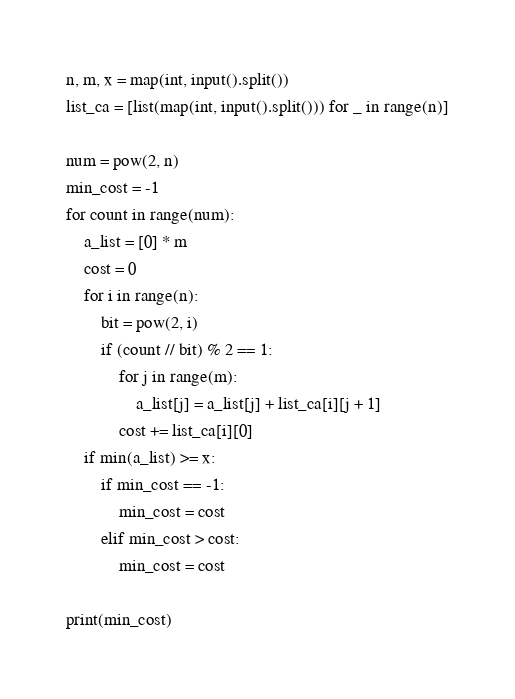<code> <loc_0><loc_0><loc_500><loc_500><_Python_>n, m, x = map(int, input().split())
list_ca = [list(map(int, input().split())) for _ in range(n)]

num = pow(2, n)
min_cost = -1
for count in range(num):
    a_list = [0] * m
    cost = 0
    for i in range(n):
        bit = pow(2, i)
        if (count // bit) % 2 == 1:
            for j in range(m):
                a_list[j] = a_list[j] + list_ca[i][j + 1]
            cost += list_ca[i][0]
    if min(a_list) >= x:
        if min_cost == -1:
            min_cost = cost
        elif min_cost > cost:
            min_cost = cost

print(min_cost)</code> 